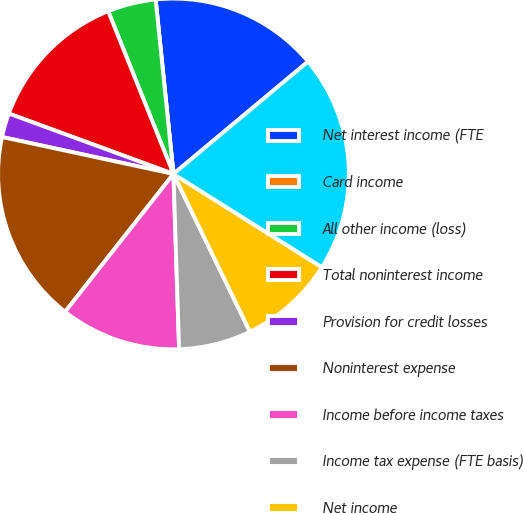Convert chart. <chart><loc_0><loc_0><loc_500><loc_500><pie_chart><fcel>Net interest income (FTE<fcel>Card income<fcel>All other income (loss)<fcel>Total noninterest income<fcel>Provision for credit losses<fcel>Noninterest expense<fcel>Income before income taxes<fcel>Income tax expense (FTE basis)<fcel>Net income<fcel>Total loans and leases<nl><fcel>15.55%<fcel>0.0%<fcel>4.45%<fcel>13.33%<fcel>2.22%<fcel>17.78%<fcel>11.11%<fcel>6.67%<fcel>8.89%<fcel>20.0%<nl></chart> 